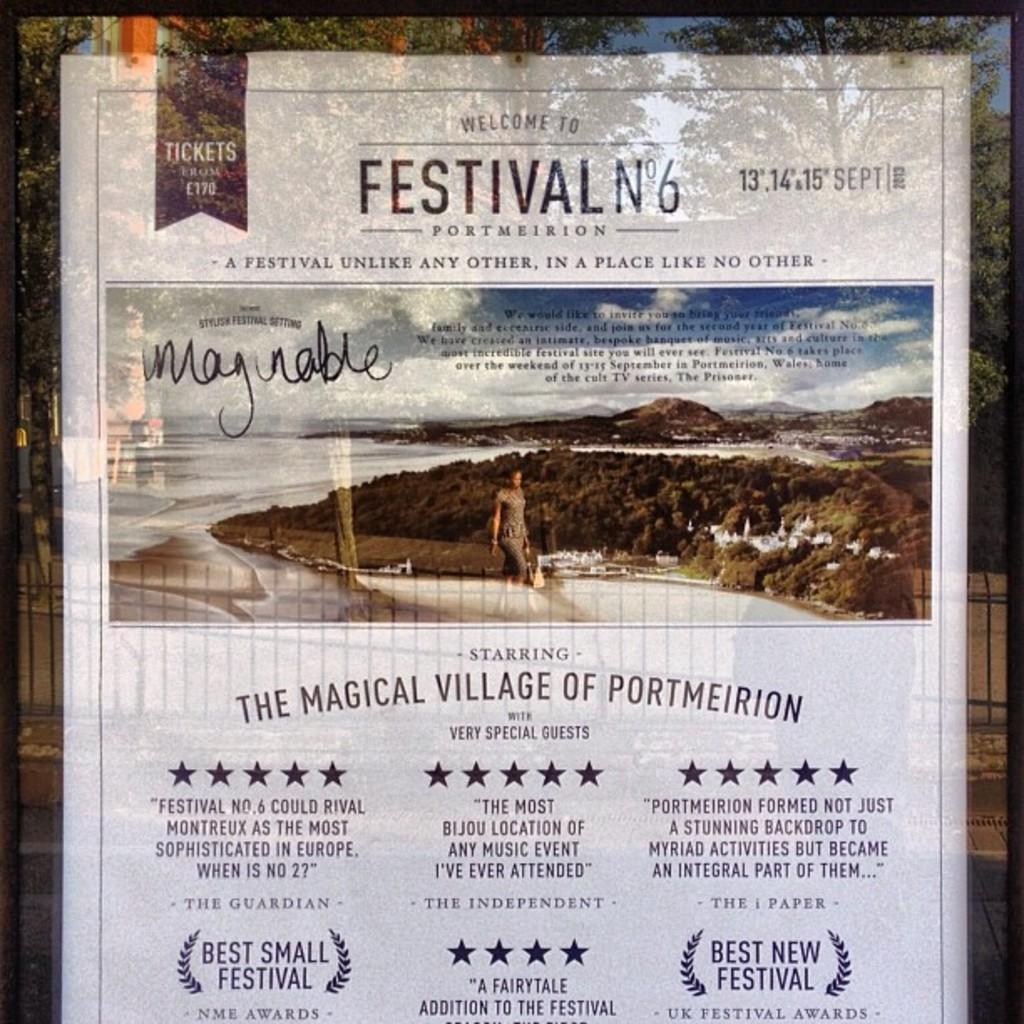<image>
Offer a succinct explanation of the picture presented. Festival N6 is occurring in Portmeirion with special guests. 